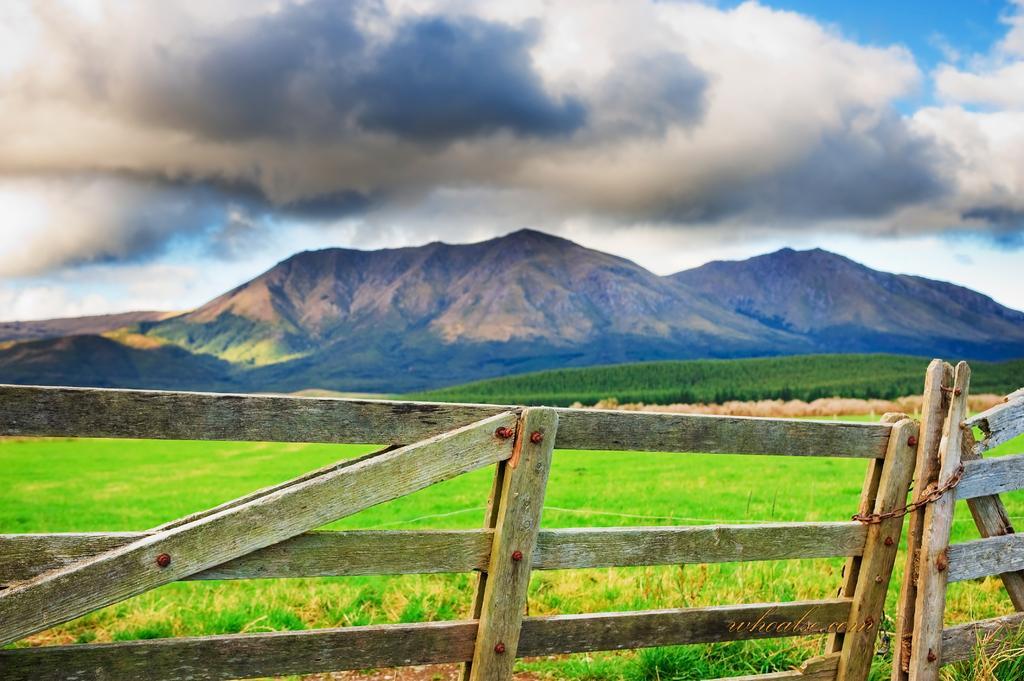In one or two sentences, can you explain what this image depicts? In the picture I can see wooden fence. In the background I can see the grass, plants, mountains and the sky. 